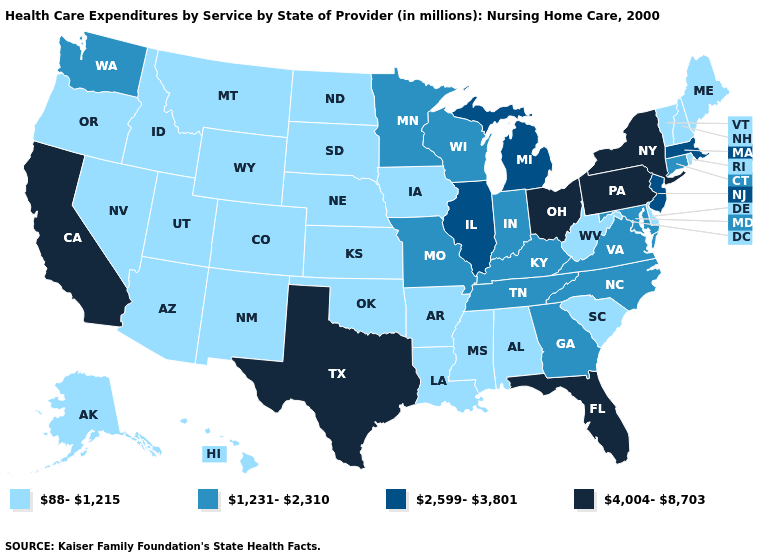Does Indiana have the highest value in the USA?
Keep it brief. No. What is the value of California?
Answer briefly. 4,004-8,703. How many symbols are there in the legend?
Give a very brief answer. 4. What is the value of Wyoming?
Concise answer only. 88-1,215. Which states have the lowest value in the South?
Write a very short answer. Alabama, Arkansas, Delaware, Louisiana, Mississippi, Oklahoma, South Carolina, West Virginia. What is the value of Kansas?
Give a very brief answer. 88-1,215. Among the states that border West Virginia , which have the highest value?
Short answer required. Ohio, Pennsylvania. Does New Mexico have a lower value than Montana?
Keep it brief. No. What is the value of Wyoming?
Concise answer only. 88-1,215. Does Ohio have the highest value in the USA?
Short answer required. Yes. Does the first symbol in the legend represent the smallest category?
Concise answer only. Yes. What is the highest value in the Northeast ?
Short answer required. 4,004-8,703. Is the legend a continuous bar?
Quick response, please. No. Which states have the highest value in the USA?
Concise answer only. California, Florida, New York, Ohio, Pennsylvania, Texas. What is the highest value in the MidWest ?
Keep it brief. 4,004-8,703. 